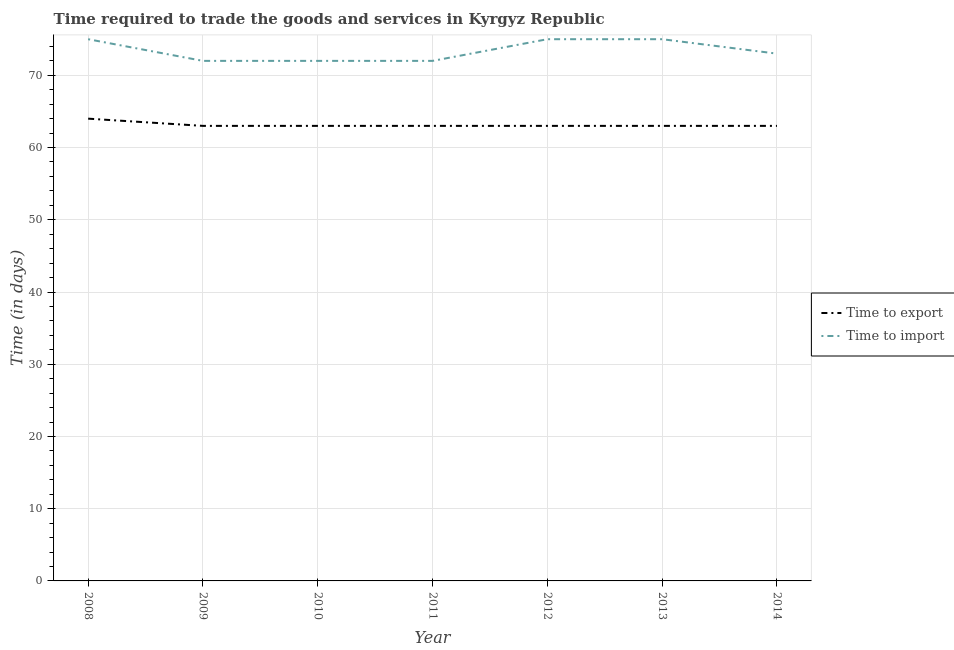How many different coloured lines are there?
Your answer should be compact. 2. Does the line corresponding to time to import intersect with the line corresponding to time to export?
Provide a succinct answer. No. Is the number of lines equal to the number of legend labels?
Keep it short and to the point. Yes. What is the time to import in 2008?
Provide a succinct answer. 75. Across all years, what is the maximum time to export?
Ensure brevity in your answer.  64. Across all years, what is the minimum time to import?
Give a very brief answer. 72. What is the total time to import in the graph?
Your response must be concise. 514. What is the difference between the time to import in 2011 and that in 2012?
Your answer should be very brief. -3. What is the difference between the time to import in 2013 and the time to export in 2009?
Keep it short and to the point. 12. What is the average time to export per year?
Offer a very short reply. 63.14. In the year 2011, what is the difference between the time to export and time to import?
Your response must be concise. -9. In how many years, is the time to export greater than 70 days?
Make the answer very short. 0. Is the time to export in 2008 less than that in 2013?
Provide a short and direct response. No. What is the difference between the highest and the lowest time to export?
Make the answer very short. 1. In how many years, is the time to import greater than the average time to import taken over all years?
Your answer should be very brief. 3. Does the time to export monotonically increase over the years?
Ensure brevity in your answer.  No. Does the graph contain any zero values?
Your response must be concise. No. Where does the legend appear in the graph?
Offer a terse response. Center right. How many legend labels are there?
Ensure brevity in your answer.  2. How are the legend labels stacked?
Give a very brief answer. Vertical. What is the title of the graph?
Your answer should be very brief. Time required to trade the goods and services in Kyrgyz Republic. Does "Agricultural land" appear as one of the legend labels in the graph?
Offer a very short reply. No. What is the label or title of the Y-axis?
Your answer should be compact. Time (in days). What is the Time (in days) in Time to import in 2009?
Provide a short and direct response. 72. What is the Time (in days) of Time to import in 2012?
Ensure brevity in your answer.  75. What is the Time (in days) in Time to export in 2014?
Provide a succinct answer. 63. What is the Time (in days) of Time to import in 2014?
Provide a succinct answer. 73. Across all years, what is the maximum Time (in days) in Time to export?
Provide a succinct answer. 64. Across all years, what is the maximum Time (in days) in Time to import?
Your response must be concise. 75. Across all years, what is the minimum Time (in days) in Time to import?
Give a very brief answer. 72. What is the total Time (in days) of Time to export in the graph?
Make the answer very short. 442. What is the total Time (in days) of Time to import in the graph?
Your answer should be very brief. 514. What is the difference between the Time (in days) of Time to export in 2008 and that in 2009?
Make the answer very short. 1. What is the difference between the Time (in days) of Time to import in 2008 and that in 2010?
Ensure brevity in your answer.  3. What is the difference between the Time (in days) in Time to import in 2008 and that in 2012?
Give a very brief answer. 0. What is the difference between the Time (in days) of Time to export in 2008 and that in 2013?
Keep it short and to the point. 1. What is the difference between the Time (in days) of Time to export in 2008 and that in 2014?
Offer a very short reply. 1. What is the difference between the Time (in days) in Time to import in 2008 and that in 2014?
Provide a short and direct response. 2. What is the difference between the Time (in days) of Time to export in 2009 and that in 2010?
Offer a terse response. 0. What is the difference between the Time (in days) of Time to export in 2009 and that in 2011?
Your answer should be very brief. 0. What is the difference between the Time (in days) in Time to import in 2009 and that in 2011?
Provide a short and direct response. 0. What is the difference between the Time (in days) of Time to export in 2009 and that in 2012?
Offer a very short reply. 0. What is the difference between the Time (in days) of Time to export in 2009 and that in 2013?
Ensure brevity in your answer.  0. What is the difference between the Time (in days) of Time to import in 2009 and that in 2014?
Offer a terse response. -1. What is the difference between the Time (in days) in Time to import in 2010 and that in 2011?
Give a very brief answer. 0. What is the difference between the Time (in days) in Time to import in 2010 and that in 2012?
Offer a terse response. -3. What is the difference between the Time (in days) of Time to export in 2010 and that in 2013?
Provide a succinct answer. 0. What is the difference between the Time (in days) of Time to import in 2010 and that in 2013?
Your answer should be compact. -3. What is the difference between the Time (in days) of Time to export in 2010 and that in 2014?
Provide a succinct answer. 0. What is the difference between the Time (in days) of Time to export in 2011 and that in 2012?
Offer a terse response. 0. What is the difference between the Time (in days) in Time to export in 2011 and that in 2013?
Your answer should be compact. 0. What is the difference between the Time (in days) in Time to import in 2011 and that in 2013?
Offer a very short reply. -3. What is the difference between the Time (in days) in Time to export in 2011 and that in 2014?
Your response must be concise. 0. What is the difference between the Time (in days) in Time to import in 2011 and that in 2014?
Offer a very short reply. -1. What is the difference between the Time (in days) in Time to import in 2012 and that in 2013?
Your answer should be very brief. 0. What is the difference between the Time (in days) of Time to export in 2012 and that in 2014?
Keep it short and to the point. 0. What is the difference between the Time (in days) in Time to import in 2012 and that in 2014?
Your answer should be very brief. 2. What is the difference between the Time (in days) in Time to import in 2013 and that in 2014?
Provide a succinct answer. 2. What is the difference between the Time (in days) of Time to export in 2008 and the Time (in days) of Time to import in 2010?
Ensure brevity in your answer.  -8. What is the difference between the Time (in days) in Time to export in 2008 and the Time (in days) in Time to import in 2012?
Offer a terse response. -11. What is the difference between the Time (in days) in Time to export in 2008 and the Time (in days) in Time to import in 2013?
Give a very brief answer. -11. What is the difference between the Time (in days) of Time to export in 2009 and the Time (in days) of Time to import in 2010?
Your response must be concise. -9. What is the difference between the Time (in days) of Time to export in 2009 and the Time (in days) of Time to import in 2012?
Offer a very short reply. -12. What is the difference between the Time (in days) in Time to export in 2009 and the Time (in days) in Time to import in 2013?
Provide a succinct answer. -12. What is the difference between the Time (in days) of Time to export in 2009 and the Time (in days) of Time to import in 2014?
Provide a short and direct response. -10. What is the difference between the Time (in days) of Time to export in 2010 and the Time (in days) of Time to import in 2013?
Your answer should be compact. -12. What is the difference between the Time (in days) of Time to export in 2011 and the Time (in days) of Time to import in 2012?
Offer a terse response. -12. What is the difference between the Time (in days) of Time to export in 2013 and the Time (in days) of Time to import in 2014?
Your answer should be compact. -10. What is the average Time (in days) in Time to export per year?
Offer a very short reply. 63.14. What is the average Time (in days) in Time to import per year?
Provide a short and direct response. 73.43. In the year 2013, what is the difference between the Time (in days) in Time to export and Time (in days) in Time to import?
Give a very brief answer. -12. In the year 2014, what is the difference between the Time (in days) of Time to export and Time (in days) of Time to import?
Make the answer very short. -10. What is the ratio of the Time (in days) of Time to export in 2008 to that in 2009?
Make the answer very short. 1.02. What is the ratio of the Time (in days) in Time to import in 2008 to that in 2009?
Your answer should be compact. 1.04. What is the ratio of the Time (in days) in Time to export in 2008 to that in 2010?
Provide a short and direct response. 1.02. What is the ratio of the Time (in days) of Time to import in 2008 to that in 2010?
Keep it short and to the point. 1.04. What is the ratio of the Time (in days) of Time to export in 2008 to that in 2011?
Make the answer very short. 1.02. What is the ratio of the Time (in days) in Time to import in 2008 to that in 2011?
Offer a terse response. 1.04. What is the ratio of the Time (in days) in Time to export in 2008 to that in 2012?
Offer a very short reply. 1.02. What is the ratio of the Time (in days) in Time to import in 2008 to that in 2012?
Your response must be concise. 1. What is the ratio of the Time (in days) in Time to export in 2008 to that in 2013?
Offer a terse response. 1.02. What is the ratio of the Time (in days) of Time to import in 2008 to that in 2013?
Your answer should be compact. 1. What is the ratio of the Time (in days) of Time to export in 2008 to that in 2014?
Provide a short and direct response. 1.02. What is the ratio of the Time (in days) of Time to import in 2008 to that in 2014?
Offer a very short reply. 1.03. What is the ratio of the Time (in days) of Time to export in 2009 to that in 2010?
Your response must be concise. 1. What is the ratio of the Time (in days) of Time to import in 2009 to that in 2011?
Provide a succinct answer. 1. What is the ratio of the Time (in days) of Time to export in 2009 to that in 2012?
Keep it short and to the point. 1. What is the ratio of the Time (in days) of Time to export in 2009 to that in 2014?
Your answer should be compact. 1. What is the ratio of the Time (in days) in Time to import in 2009 to that in 2014?
Keep it short and to the point. 0.99. What is the ratio of the Time (in days) of Time to export in 2010 to that in 2011?
Offer a very short reply. 1. What is the ratio of the Time (in days) of Time to export in 2010 to that in 2012?
Keep it short and to the point. 1. What is the ratio of the Time (in days) of Time to import in 2010 to that in 2012?
Your answer should be compact. 0.96. What is the ratio of the Time (in days) in Time to export in 2010 to that in 2013?
Offer a terse response. 1. What is the ratio of the Time (in days) in Time to import in 2010 to that in 2014?
Make the answer very short. 0.99. What is the ratio of the Time (in days) in Time to export in 2011 to that in 2012?
Make the answer very short. 1. What is the ratio of the Time (in days) in Time to import in 2011 to that in 2012?
Your answer should be very brief. 0.96. What is the ratio of the Time (in days) of Time to import in 2011 to that in 2013?
Provide a short and direct response. 0.96. What is the ratio of the Time (in days) in Time to import in 2011 to that in 2014?
Keep it short and to the point. 0.99. What is the ratio of the Time (in days) in Time to export in 2012 to that in 2013?
Offer a terse response. 1. What is the ratio of the Time (in days) in Time to import in 2012 to that in 2014?
Keep it short and to the point. 1.03. What is the ratio of the Time (in days) in Time to export in 2013 to that in 2014?
Offer a terse response. 1. What is the ratio of the Time (in days) in Time to import in 2013 to that in 2014?
Make the answer very short. 1.03. What is the difference between the highest and the lowest Time (in days) in Time to import?
Provide a succinct answer. 3. 